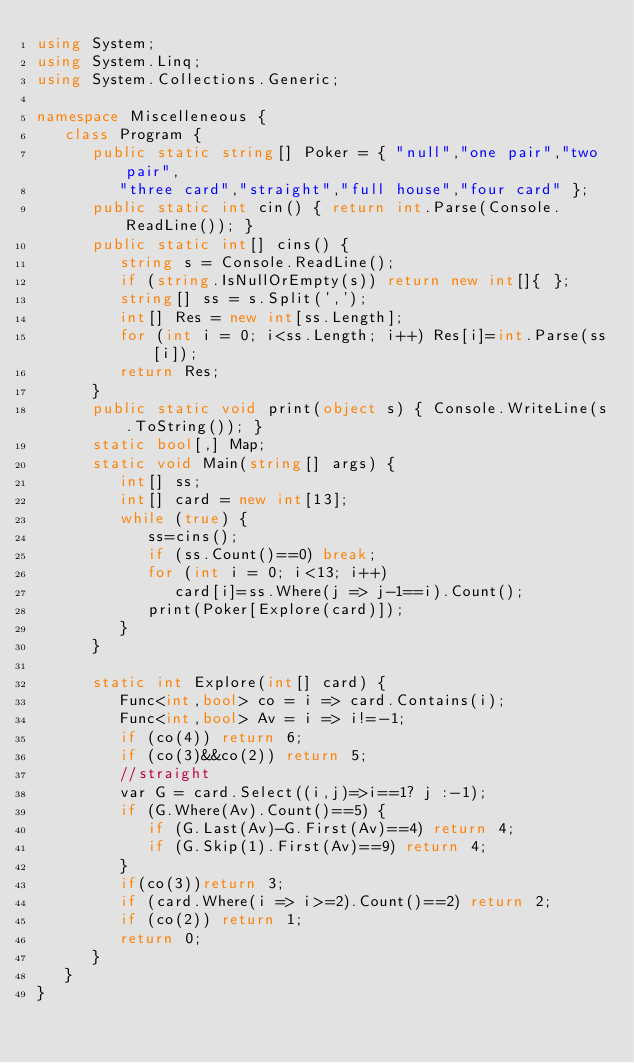Convert code to text. <code><loc_0><loc_0><loc_500><loc_500><_C#_>using System;
using System.Linq;
using System.Collections.Generic;

namespace Miscelleneous {
   class Program {
      public static string[] Poker = { "null","one pair","two pair",
         "three card","straight","full house","four card" };
      public static int cin() { return int.Parse(Console.ReadLine()); }
      public static int[] cins() {
         string s = Console.ReadLine();
         if (string.IsNullOrEmpty(s)) return new int[]{ };
         string[] ss = s.Split(',');
         int[] Res = new int[ss.Length];
         for (int i = 0; i<ss.Length; i++) Res[i]=int.Parse(ss[i]);
         return Res;
      }
      public static void print(object s) { Console.WriteLine(s.ToString()); }
      static bool[,] Map;
      static void Main(string[] args) {
         int[] ss;
         int[] card = new int[13];
         while (true) {
            ss=cins();
            if (ss.Count()==0) break;
            for (int i = 0; i<13; i++)
               card[i]=ss.Where(j => j-1==i).Count();
            print(Poker[Explore(card)]);
         }
      }

      static int Explore(int[] card) {
         Func<int,bool> co = i => card.Contains(i);
         Func<int,bool> Av = i => i!=-1;
         if (co(4)) return 6;
         if (co(3)&&co(2)) return 5;
         //straight
         var G = card.Select((i,j)=>i==1? j :-1);
         if (G.Where(Av).Count()==5) {
            if (G.Last(Av)-G.First(Av)==4) return 4;
            if (G.Skip(1).First(Av)==9) return 4;
         }
         if(co(3))return 3;
         if (card.Where(i => i>=2).Count()==2) return 2;
         if (co(2)) return 1;
         return 0;
      }
   }
}</code> 